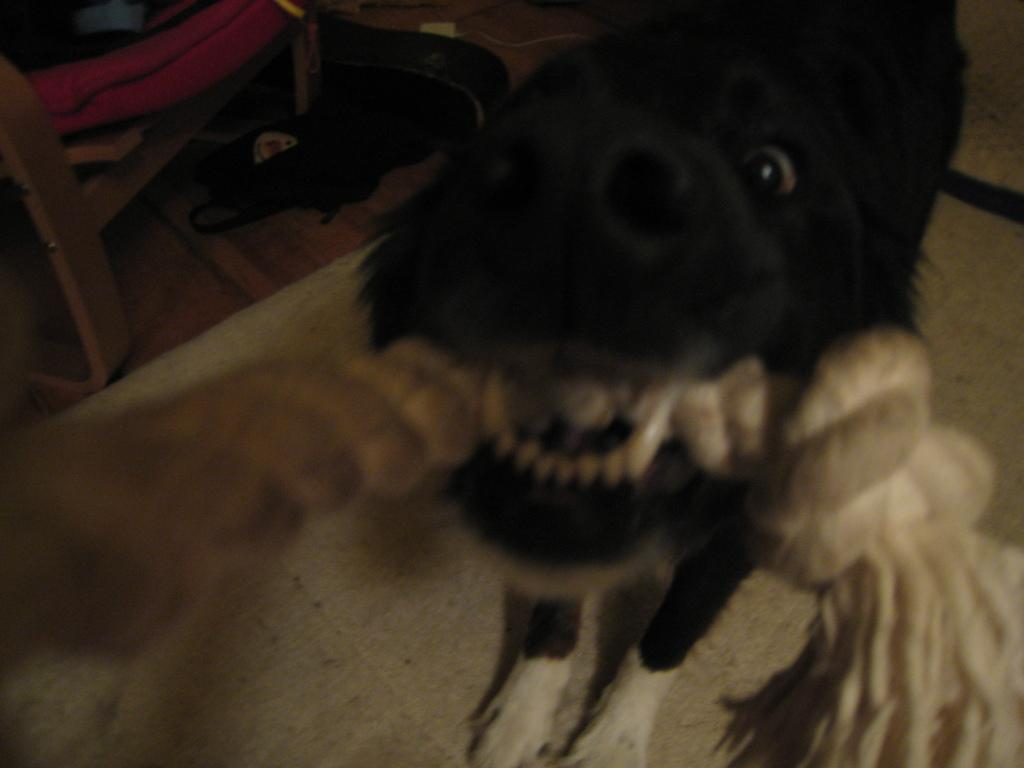What is the dog in the image doing with an object in its mouth? The dog in the image is holding an object in its mouth. What is the position of the other dog in the image? The other dog is lying on the floor in the image. What type of furniture can be seen in the image? There is a chair in the image. What type of flesh can be seen on the chair in the image? There is no flesh visible on the chair in the image. What color is the patch on the dog's fur in the image? There is no patch mentioned on the dog's fur in the image. 